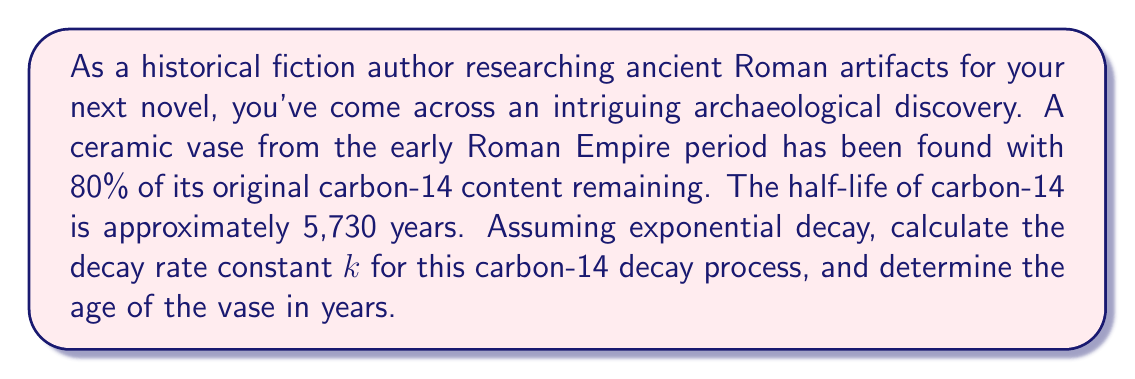Give your solution to this math problem. To solve this problem, we'll use the exponential decay model and the given information about carbon-14 decay. Let's approach this step-by-step:

1) The exponential decay model is given by the equation:

   $$N(t) = N_0 e^{-kt}$$

   Where:
   $N(t)$ is the amount remaining at time $t$
   $N_0$ is the initial amount
   $k$ is the decay rate constant
   $t$ is time

2) We're told that 80% of the original carbon-14 content remains. This means:

   $$\frac{N(t)}{N_0} = 0.80$$

3) Substituting this into our exponential decay equation:

   $$0.80 = e^{-kt}$$

4) We're also given information about the half-life. The half-life $t_{1/2}$ is related to the decay constant $k$ by:

   $$t_{1/2} = \frac{\ln(2)}{k}$$

5) Rearranging this, we get:

   $$k = \frac{\ln(2)}{t_{1/2}} = \frac{\ln(2)}{5730} \approx 1.209 \times 10^{-4} \text{ year}^{-1}$$

6) Now that we have $k$, we can solve for $t$ in our original equation:

   $$0.80 = e^{-kt}$$
   $$\ln(0.80) = -kt$$
   $$t = -\frac{\ln(0.80)}{k} = -\frac{\ln(0.80)}{1.209 \times 10^{-4}} \approx 1842 \text{ years}$$

Thus, the vase is approximately 1842 years old.
Answer: The decay rate constant $k$ is approximately $1.209 \times 10^{-4} \text{ year}^{-1}$, and the age of the vase is approximately 1842 years. 